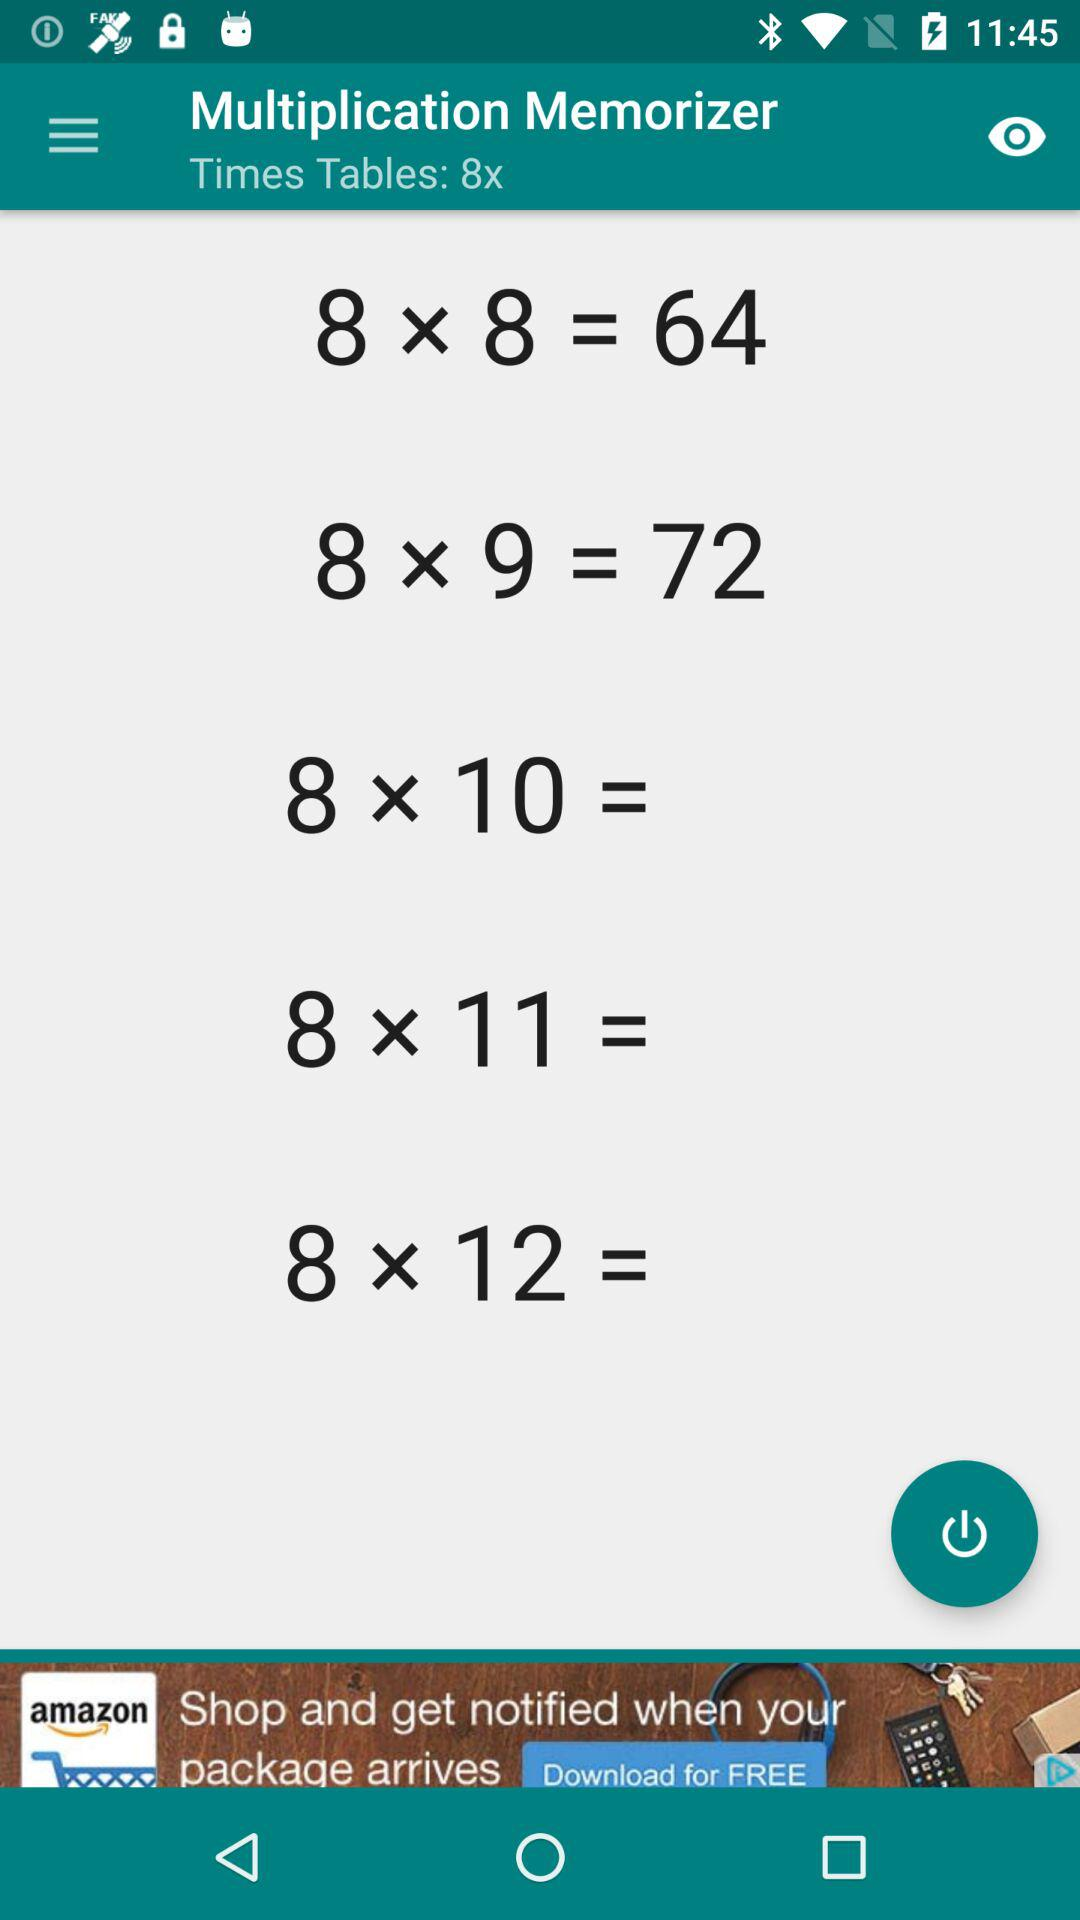For what number is the time table? The time table is for number 8. 